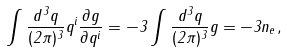<formula> <loc_0><loc_0><loc_500><loc_500>\int \frac { d ^ { 3 } q } { ( 2 \pi ) ^ { 3 } } q ^ { i } \frac { \partial g } { \partial q ^ { i } } = - 3 \int \frac { d ^ { 3 } q } { ( 2 \pi ) ^ { 3 } } g = - 3 n _ { e } \, ,</formula> 